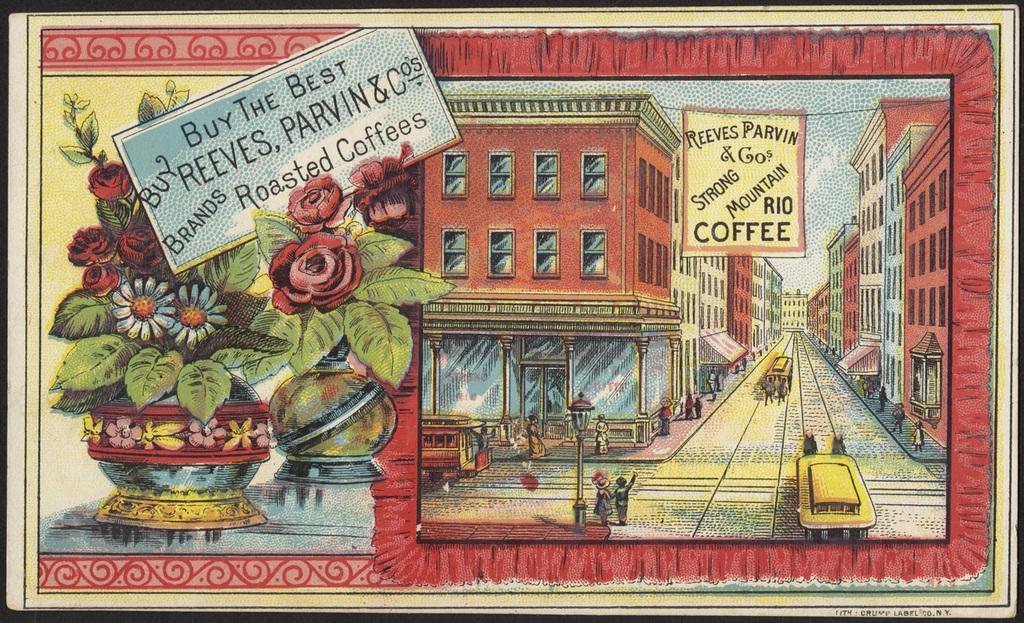Provide a one-sentence caption for the provided image. An old advertisement for Reeves Parvin & Co's roasted coffee that has an old new york buildings setting in cartoon style artwork. 